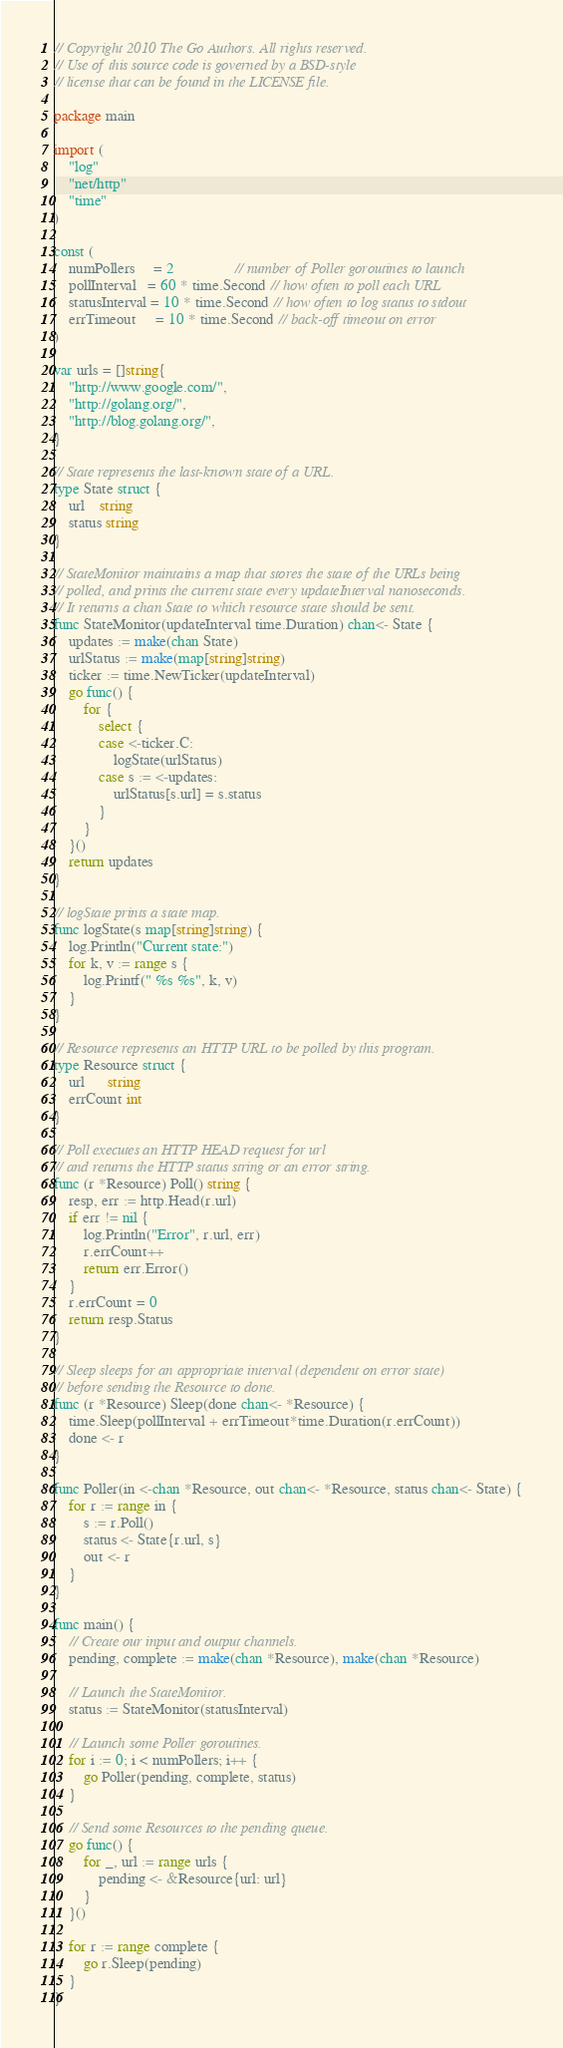<code> <loc_0><loc_0><loc_500><loc_500><_Go_>// Copyright 2010 The Go Authors. All rights reserved.
// Use of this source code is governed by a BSD-style
// license that can be found in the LICENSE file.

package main

import (
	"log"
	"net/http"
	"time"
)

const (
	numPollers     = 2                // number of Poller goroutines to launch
	pollInterval   = 60 * time.Second // how often to poll each URL
	statusInterval = 10 * time.Second // how often to log status to stdout
	errTimeout     = 10 * time.Second // back-off timeout on error
)

var urls = []string{
	"http://www.google.com/",
	"http://golang.org/",
	"http://blog.golang.org/",
}

// State represents the last-known state of a URL.
type State struct {
	url    string
	status string
}

// StateMonitor maintains a map that stores the state of the URLs being
// polled, and prints the current state every updateInterval nanoseconds.
// It returns a chan State to which resource state should be sent.
func StateMonitor(updateInterval time.Duration) chan<- State {
	updates := make(chan State)
	urlStatus := make(map[string]string)
	ticker := time.NewTicker(updateInterval)
	go func() {
		for {
			select {
			case <-ticker.C:
				logState(urlStatus)
			case s := <-updates:
				urlStatus[s.url] = s.status
			}
		}
	}()
	return updates
}

// logState prints a state map.
func logState(s map[string]string) {
	log.Println("Current state:")
	for k, v := range s {
		log.Printf(" %s %s", k, v)
	}
}

// Resource represents an HTTP URL to be polled by this program.
type Resource struct {
	url      string
	errCount int
}

// Poll executes an HTTP HEAD request for url
// and returns the HTTP status string or an error string.
func (r *Resource) Poll() string {
	resp, err := http.Head(r.url)
	if err != nil {
		log.Println("Error", r.url, err)
		r.errCount++
		return err.Error()
	}
	r.errCount = 0
	return resp.Status
}

// Sleep sleeps for an appropriate interval (dependent on error state)
// before sending the Resource to done.
func (r *Resource) Sleep(done chan<- *Resource) {
	time.Sleep(pollInterval + errTimeout*time.Duration(r.errCount))
	done <- r
}

func Poller(in <-chan *Resource, out chan<- *Resource, status chan<- State) {
	for r := range in {
		s := r.Poll()
		status <- State{r.url, s}
		out <- r
	}
}

func main() {
	// Create our input and output channels.
	pending, complete := make(chan *Resource), make(chan *Resource)

	// Launch the StateMonitor.
	status := StateMonitor(statusInterval)

	// Launch some Poller goroutines.
	for i := 0; i < numPollers; i++ {
		go Poller(pending, complete, status)
	}

	// Send some Resources to the pending queue.
	go func() {
		for _, url := range urls {
			pending <- &Resource{url: url}
		}
	}()

	for r := range complete {
		go r.Sleep(pending)
	}
}</code> 